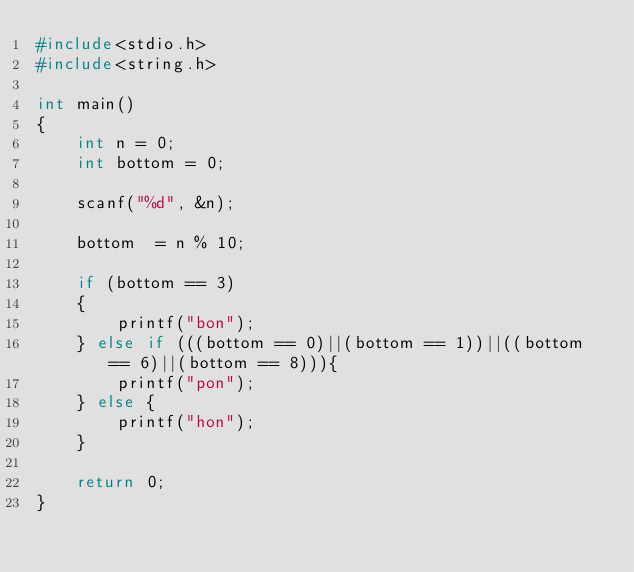Convert code to text. <code><loc_0><loc_0><loc_500><loc_500><_C_>#include<stdio.h>
#include<string.h>

int main()
{
    int n = 0;
    int bottom = 0;

    scanf("%d", &n);

    bottom  = n % 10;

    if (bottom == 3)
    {
        printf("bon");
    } else if (((bottom == 0)||(bottom == 1))||((bottom == 6)||(bottom == 8))){
        printf("pon");
    } else {
        printf("hon");
    }  

    return 0;
}</code> 